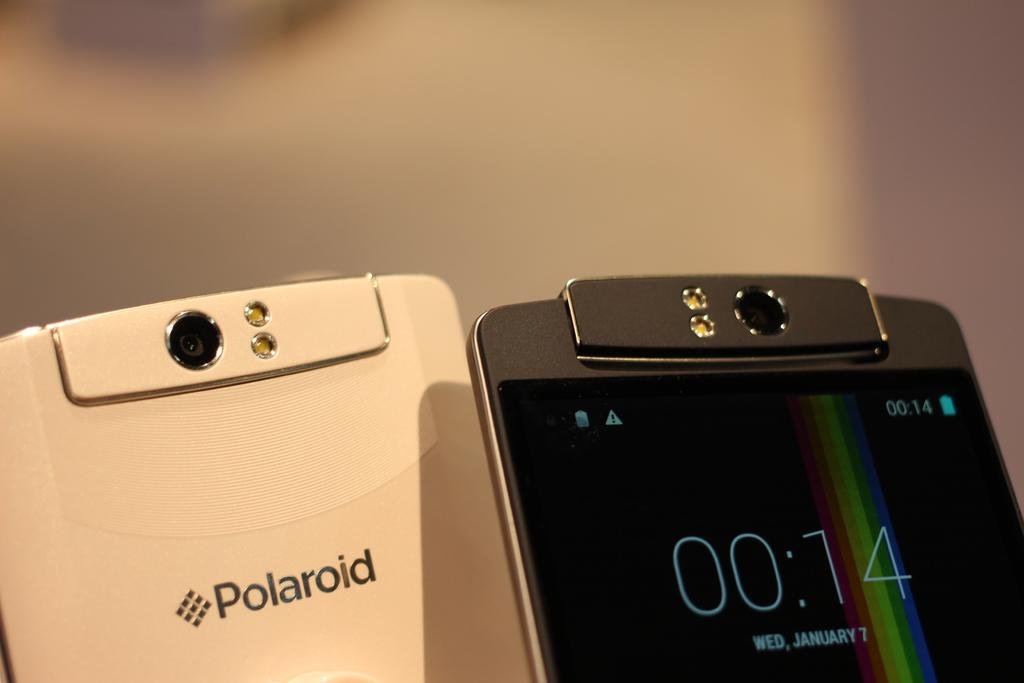<image>
Provide a brief description of the given image. A polaroid brand phone sits next to a phone stating that today is January 7. 